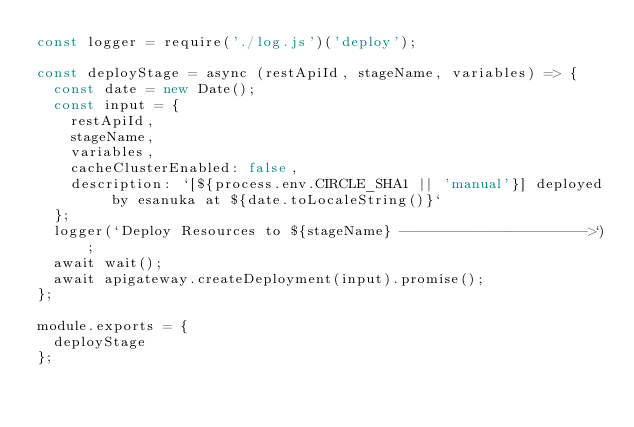<code> <loc_0><loc_0><loc_500><loc_500><_JavaScript_>const logger = require('./log.js')('deploy');

const deployStage = async (restApiId, stageName, variables) => {
  const date = new Date();
  const input = {
    restApiId,
    stageName,
    variables,
    cacheClusterEnabled: false,
    description: `[${process.env.CIRCLE_SHA1 || 'manual'}] deployed by esanuka at ${date.toLocaleString()}`
  };
  logger(`Deploy Resources to ${stageName} --------------------->`);
  await wait();
  await apigateway.createDeployment(input).promise();
};

module.exports = {
  deployStage
};
</code> 